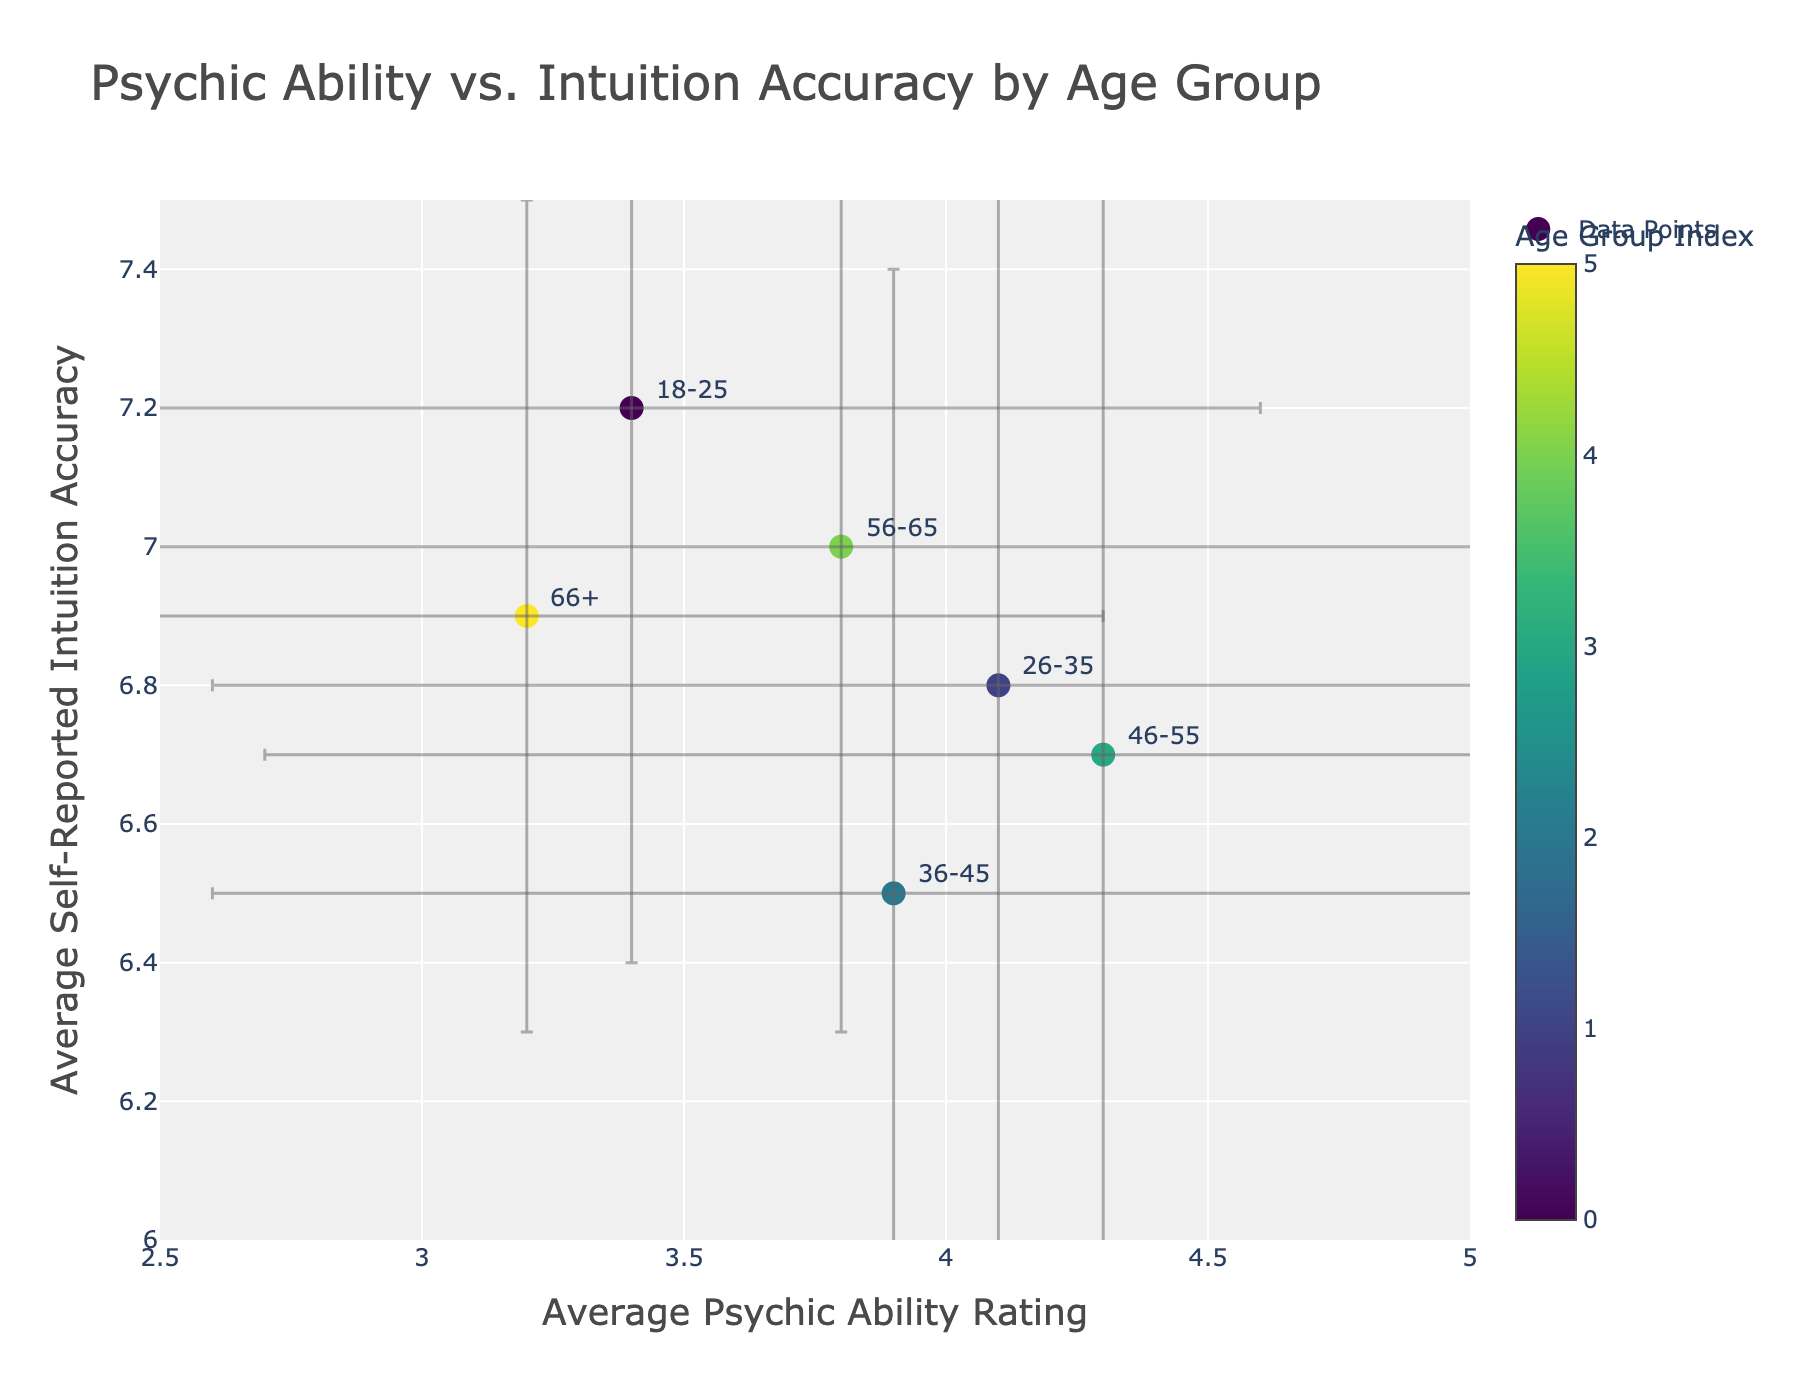What is the title of the plot? The title of the plot is displayed at the top center of the figure. It reads, "Psychic Ability vs. Intuition Accuracy by Age Group".
Answer: Psychic Ability vs. Intuition Accuracy by Age Group What is the x-axis label? The x-axis label is located below the x-axis and reads, "Average Psychic Ability Rating".
Answer: Average Psychic Ability Rating Which age group has the highest average psychic ability rating? By looking at the x-axis, the 46-55 age group has the highest average psychic ability rating of 4.3.
Answer: 46-55 Which age group has the lowest average self-reported intuition accuracy? By examining the y-axis, the 36-45 age group has the lowest average self-reported intuition accuracy of 6.5.
Answer: 36-45 Do older age groups generally report higher or lower intuition accuracy compared to younger age groups? By comparing the y-axis values across the age groups, older age groups, such as 56-65 and 66+, report modestly high intuition accuracy (around 6.9-7.0) compared to younger age groups (such as 6.5-6.8 for 26-45).
Answer: Higher What is the standard deviation of psychic ability for the 26-35 age group? The data point for the 26-35 age group includes an error bar along the x-axis which indicates the standard deviation is 1.5.
Answer: 1.5 Which age group has the smallest error in self-reported intuition accuracy? The error bars along the y-axis show that the 66+ age group has the smallest error bar indicating a standard deviation of 0.6.
Answer: 66+ How many age groups are shown in the plot? There are six unique colors representing six different age groups in the plot, which can also be confirmed by counting the annotations.
Answer: 6 Which age group has the most similar average ratings for both psychic ability and self-reported intuition accuracy? By comparing the x and y values, the 56-65 age group has the closest average ratings: around 3.8 for psychic ability and 7.0 for intuition accuracy.
Answer: 56-65 